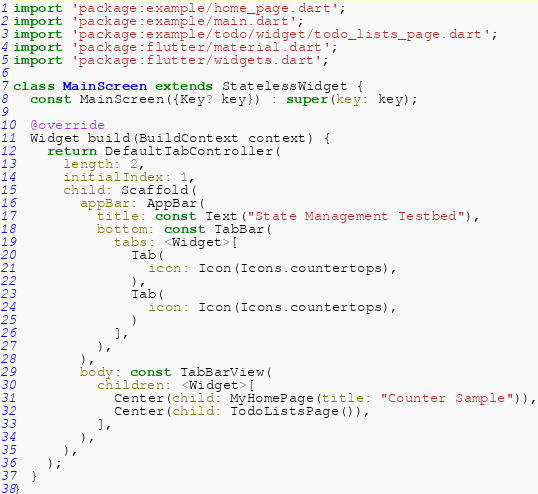Convert code to text. <code><loc_0><loc_0><loc_500><loc_500><_Dart_>import 'package:example/home_page.dart';
import 'package:example/main.dart';
import 'package:example/todo/widget/todo_lists_page.dart';
import 'package:flutter/material.dart';
import 'package:flutter/widgets.dart';

class MainScreen extends StatelessWidget {
  const MainScreen({Key? key}) : super(key: key);

  @override
  Widget build(BuildContext context) {
    return DefaultTabController(
      length: 2,
      initialIndex: 1,
      child: Scaffold(
        appBar: AppBar(
          title: const Text("State Management Testbed"),
          bottom: const TabBar(
            tabs: <Widget>[
              Tab(
                icon: Icon(Icons.countertops),
              ),
              Tab(
                icon: Icon(Icons.countertops),
              )
            ],
          ),
        ),
        body: const TabBarView(
          children: <Widget>[
            Center(child: MyHomePage(title: "Counter Sample")),
            Center(child: TodoListsPage()),
          ],
        ),
      ),
    );
  }
}
</code> 